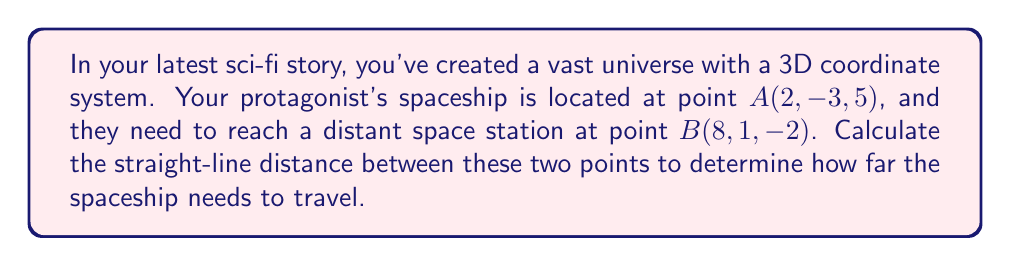Give your solution to this math problem. To find the distance between two points in a 3D coordinate system, we use the distance formula, which is an extension of the Pythagorean theorem to three dimensions:

$$d = \sqrt{(x_2-x_1)^2 + (y_2-y_1)^2 + (z_2-z_1)^2}$$

Where $(x_1, y_1, z_1)$ are the coordinates of the first point and $(x_2, y_2, z_2)$ are the coordinates of the second point.

Let's substitute the given coordinates:
Point A: $(x_1, y_1, z_1) = (2, -3, 5)$
Point B: $(x_2, y_2, z_2) = (8, 1, -2)$

Now, let's calculate each term inside the square root:

1. $(x_2-x_1)^2 = (8-2)^2 = 6^2 = 36$
2. $(y_2-y_1)^2 = (1-(-3))^2 = 4^2 = 16$
3. $(z_2-z_1)^2 = (-2-5)^2 = (-7)^2 = 49$

Substituting these values into the formula:

$$d = \sqrt{36 + 16 + 49}$$
$$d = \sqrt{101}$$

The square root of 101 cannot be simplified further, so this is our final answer.
Answer: $\sqrt{101}$ units 